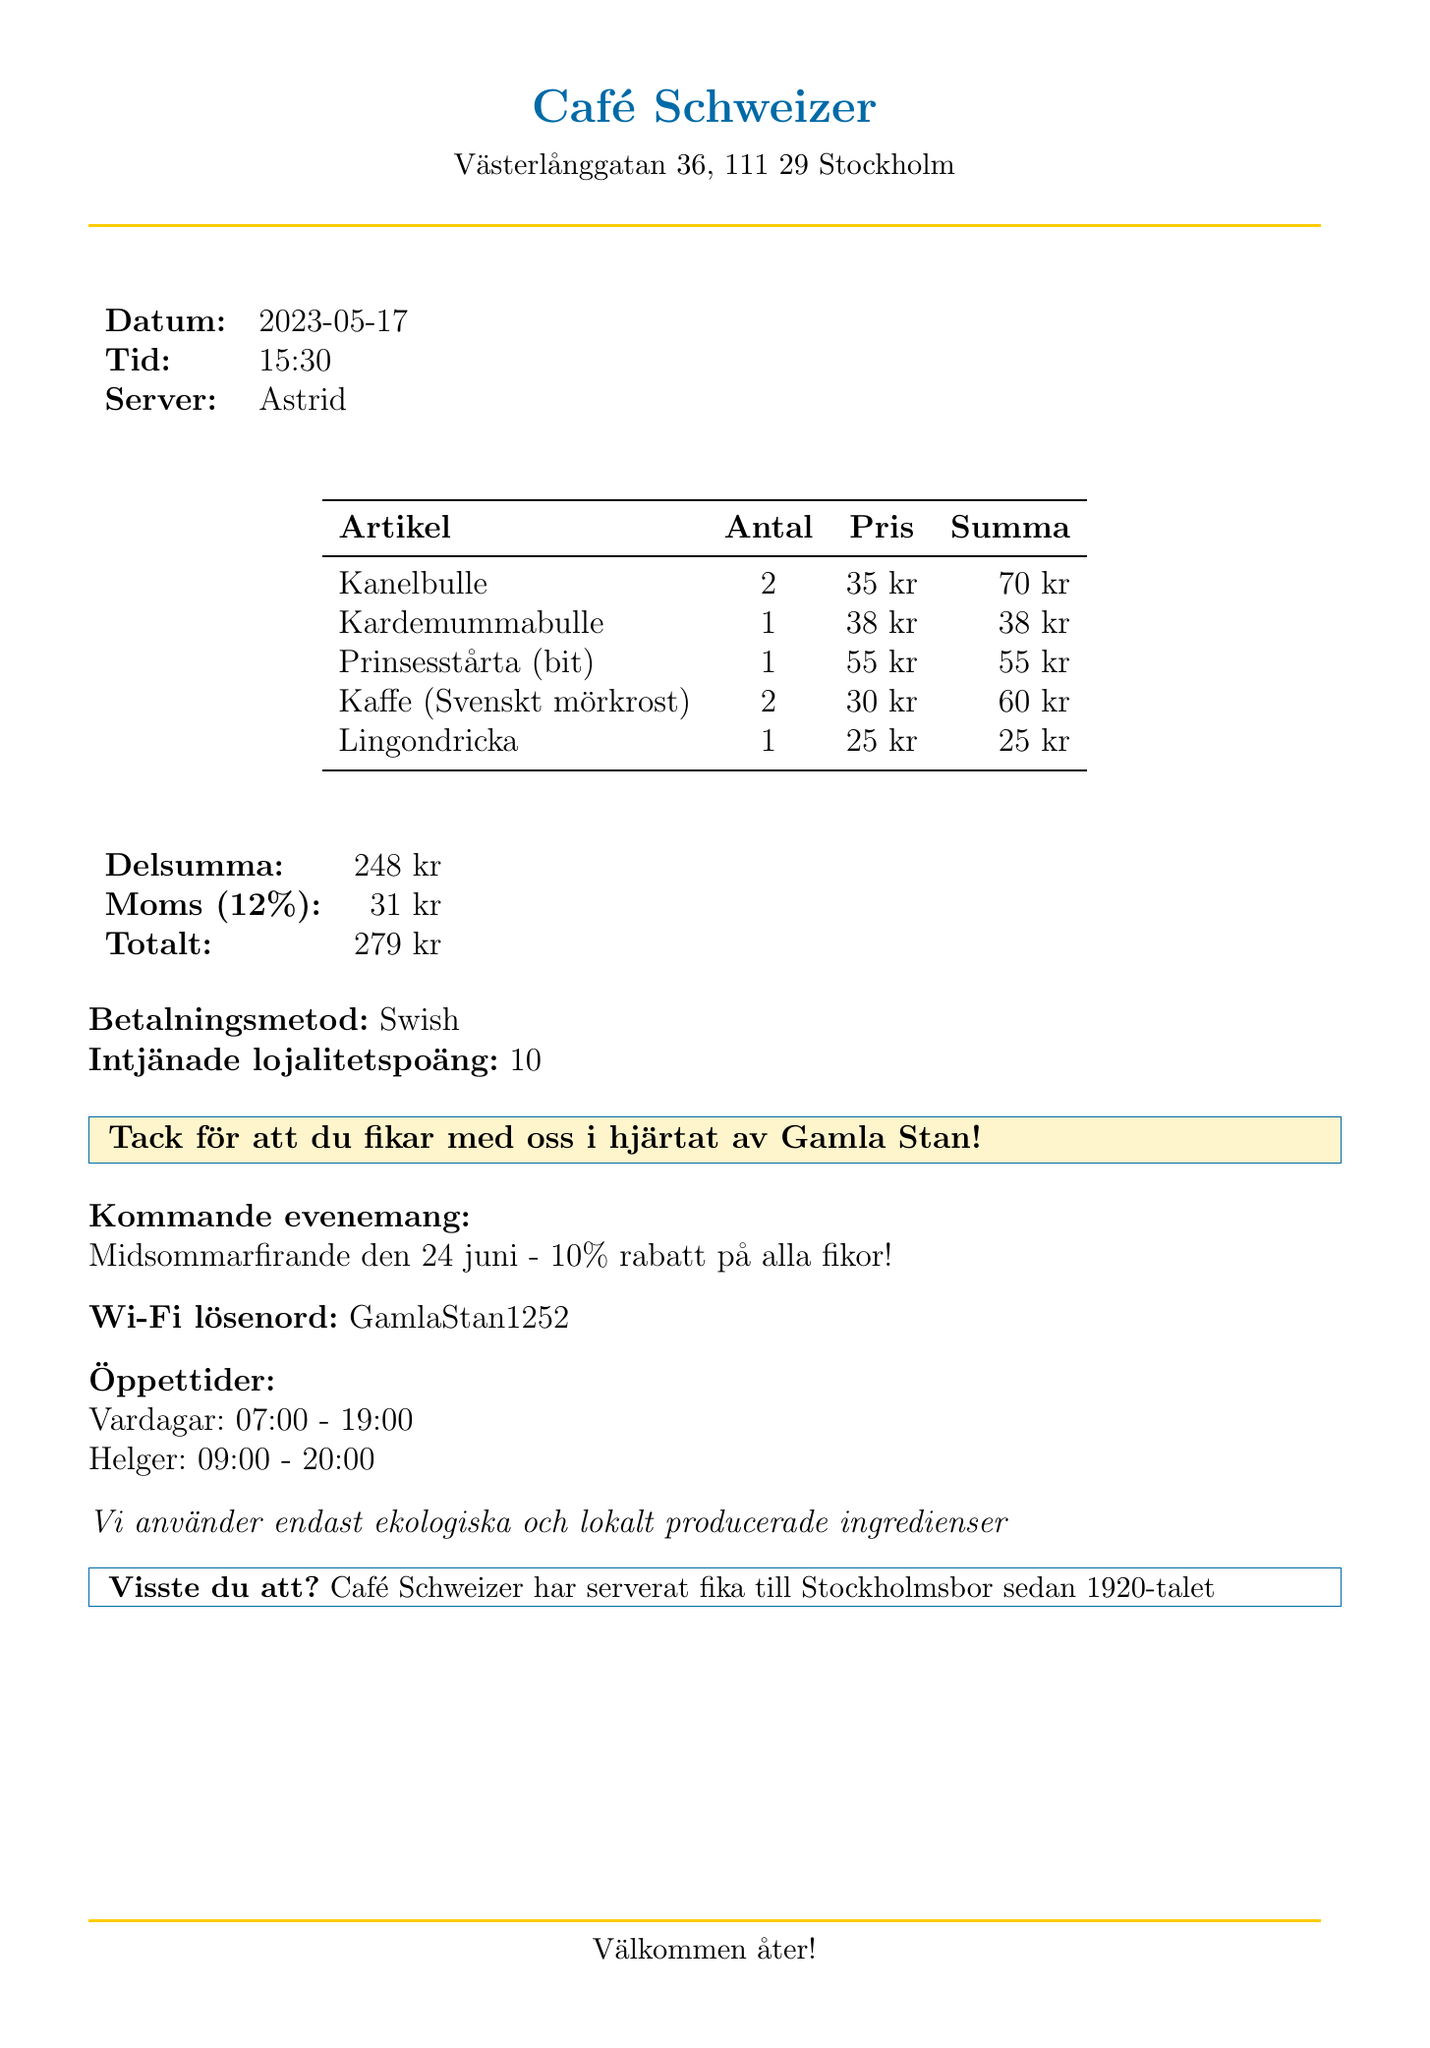What is the café's name? The café's name is provided in the document's header.
Answer: Café Schweizer What is the date of the visit? The date of the visit is mentioned under the date section of the document.
Answer: 2023-05-17 How many Kanelbullar were ordered? The quantity of Kanelbullar can be found in the items list on the receipt.
Answer: 2 What is the total amount spent? The total amount is listed at the end of the receipt in the total section.
Answer: 279 kr Who served the fika? The name of the server is indicated in the document.
Answer: Astrid What payment method was used? The payment method is specified towards the end of the receipt.
Answer: Swish How many loyalty points were earned? The earned loyalty points are noted in the receipt details.
Answer: 10 What is the special note on the receipt? The special note is highlighted in the document to thank the customer.
Answer: Tack för att du fikar med oss i hjärtat av Gamla Stan! When is the upcoming event? The upcoming event information is listed towards the end of the document.
Answer: Midsommarfirande den 24 juni What information is provided about sustainability? The sustainability information is included in the document's details section.
Answer: Vi använder endast ekologiska och lokalt producerade ingredienser 